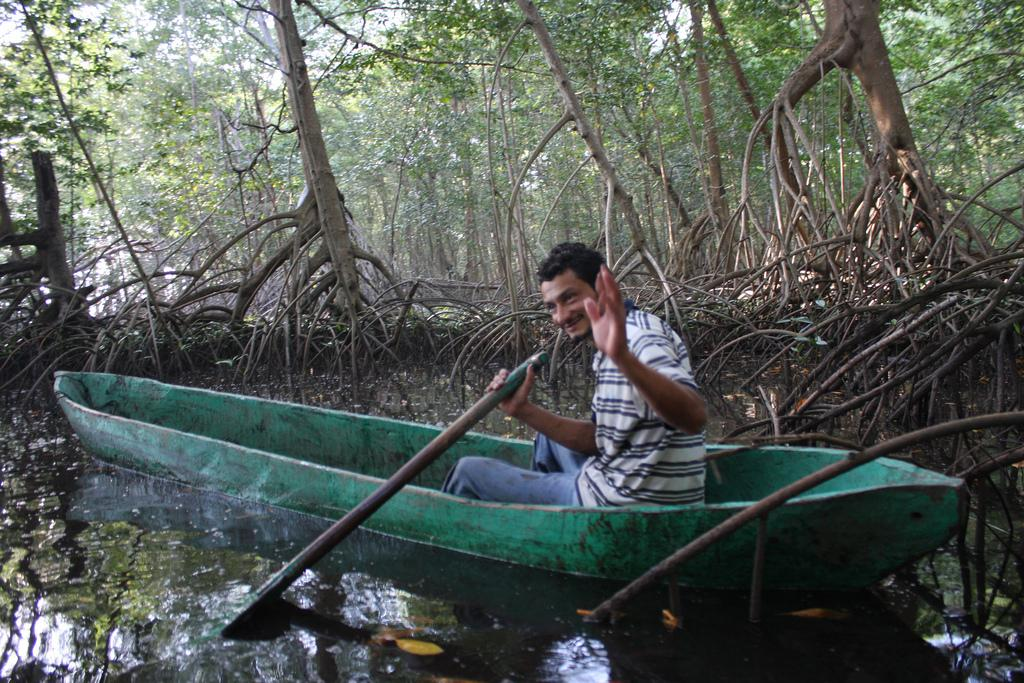What is the person in the image doing? The person is sitting in a boat in the image. What is the person holding in his hand? The person is holding a stick in his hand. What can be seen in the background of the image? There is a group of trees, leaves, and the sky visible in the background of the image. What type of wilderness apparatus is visible in the image? There is no wilderness apparatus present in the image. 